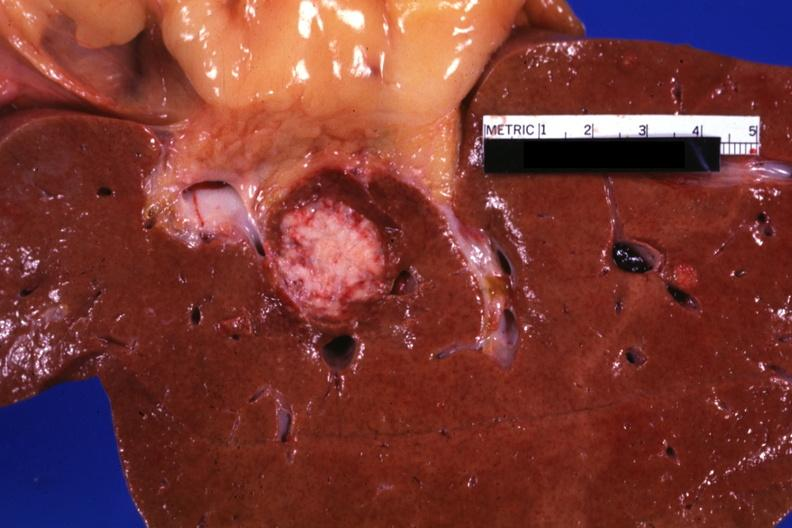what is present?
Answer the question using a single word or phrase. Hepatobiliary 